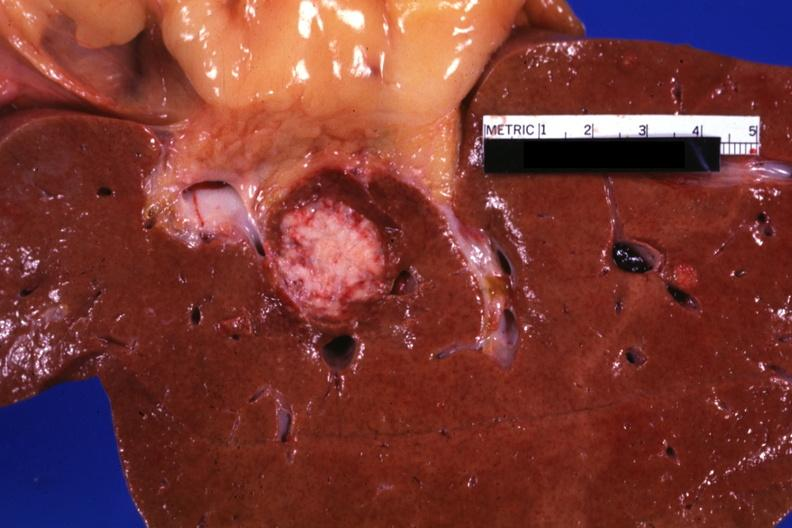what is present?
Answer the question using a single word or phrase. Hepatobiliary 